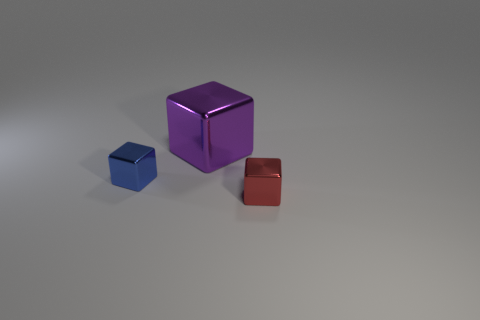Do the cube in front of the blue block and the blue thing have the same size?
Offer a very short reply. Yes. What color is the other tiny shiny object that is the same shape as the small blue shiny thing?
Your answer should be compact. Red. The blue shiny object on the left side of the cube in front of the small block to the left of the red block is what shape?
Make the answer very short. Cube. Is the shape of the large metallic thing the same as the blue metal object?
Provide a succinct answer. Yes. The object that is in front of the tiny metallic thing that is left of the red shiny thing is what shape?
Ensure brevity in your answer.  Cube. Is there a tiny blue metal object?
Offer a terse response. Yes. There is a tiny object that is to the right of the metallic cube that is on the left side of the purple metallic block; what number of red cubes are behind it?
Provide a succinct answer. 0. Do the big purple object and the tiny object that is behind the tiny red metallic object have the same shape?
Give a very brief answer. Yes. Are there more small metal cubes than brown rubber cubes?
Your answer should be compact. Yes. Are there any other things that have the same size as the purple metal cube?
Your response must be concise. No. 